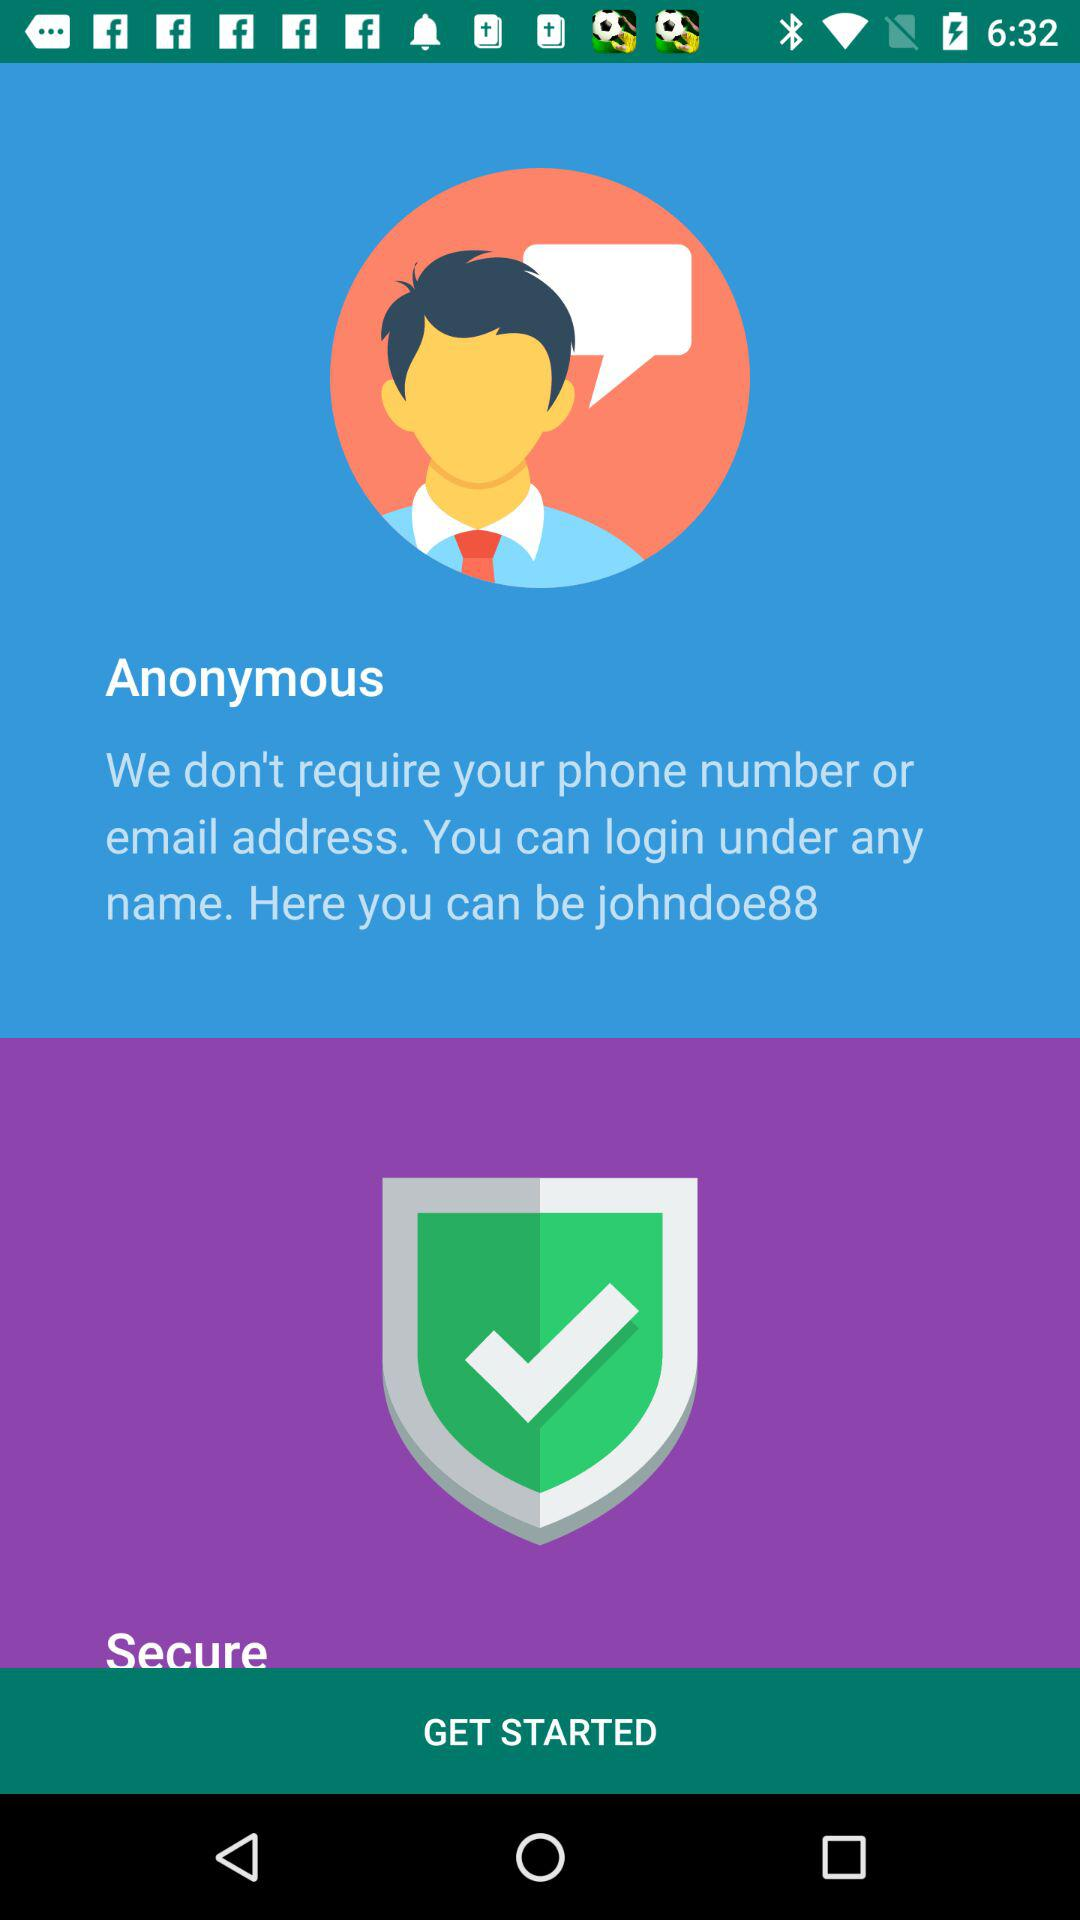What is not required to log in? To log in, a phone number or email address is not required. 